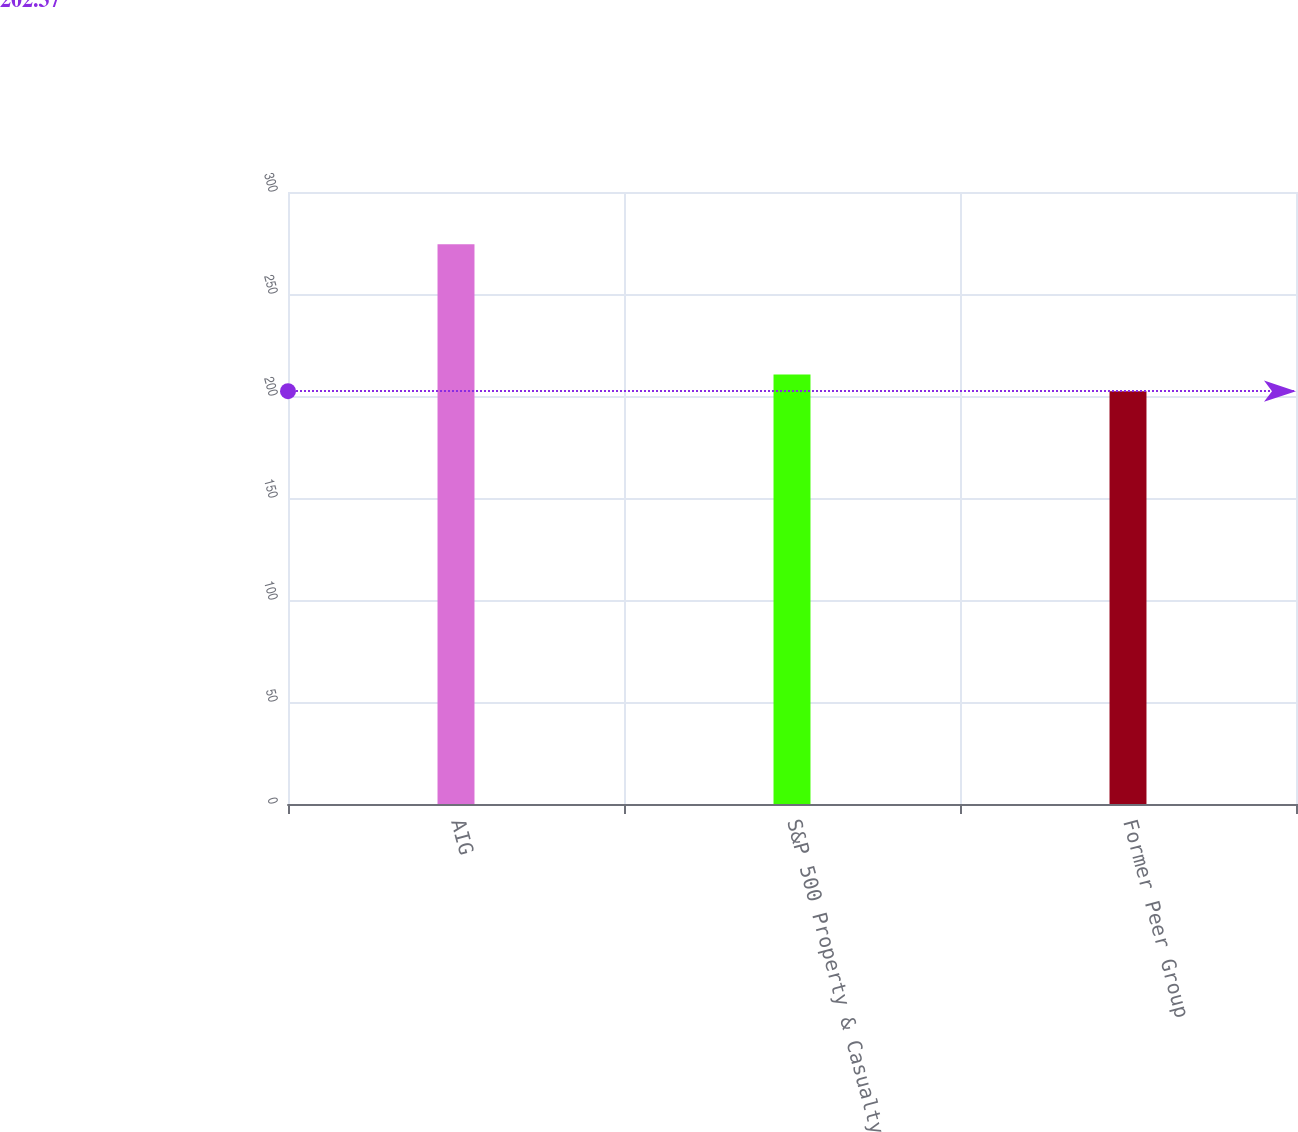Convert chart to OTSL. <chart><loc_0><loc_0><loc_500><loc_500><bar_chart><fcel>AIG<fcel>S&P 500 Property & Casualty<fcel>Former Peer Group<nl><fcel>274.44<fcel>210.57<fcel>202.37<nl></chart> 